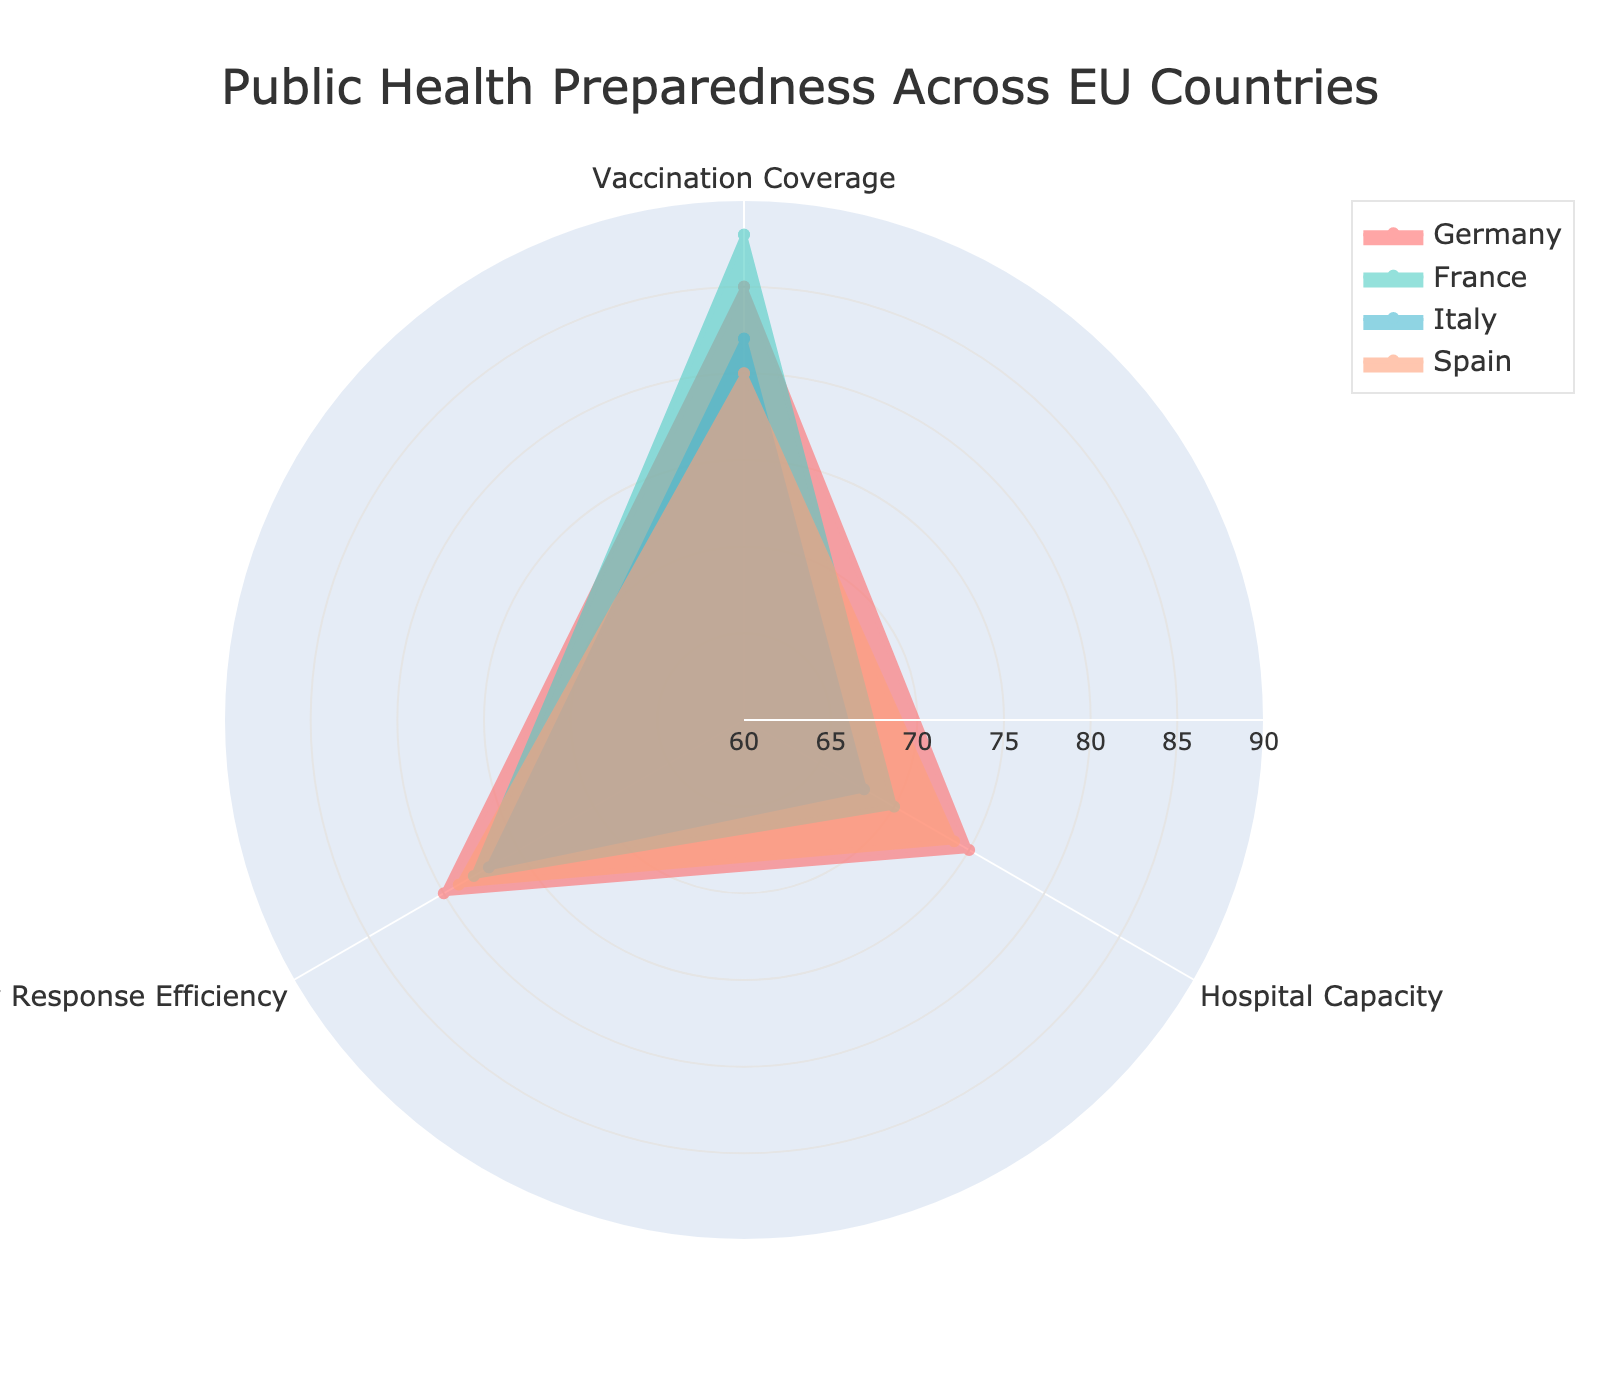What's the title of the radar chart? The title is located prominently at the top center of the radar chart. It reads 'Public Health Preparedness Across EU Countries'.
Answer: Public Health Preparedness Across EU Countries Which country has the highest Vaccination Coverage? By looking at the Vaccination Coverage indicator, the country with the highest value is plotted the farthest from the center. It can be observed that France has the highest value at 88%.
Answer: France What is the overall range of values for the Hospital Capacity indicator? The Hospital Capacity indicator can be observed along one axis of the radar chart. The lowest value is for Italy at 68%, and the highest value is for Germany at 75%. Thus, the range is from 68% to 75%.
Answer: 68% to 75% Compare the Emergency Response Efficiency of Germany and Spain. Which country performs better? In the Emergency Response Efficiency indicator, Germany and Spain can be compared by looking at their respective positions along this dimension. Germany scores 80%, whereas Spain scores 79%. Thus, Germany performs slightly better.
Answer: Germany What is the average Vaccination Coverage across all the countries? The Vaccination Coverage values for all countries are Germany (85), France (88), Italy (82), and Spain (80). The average is calculated as (85 + 88 + 82 + 80) / 4 = 83.75.
Answer: 83.75 Which country has the smallest value for any indicator, and what is that value? Observe the innermost data points on each axis. Italy has the smallest value for Hospital Capacity at 68%.
Answer: Italy, 68% Which indicator shows the largest variation across the countries? To determine variation, observe the spread of values for each indicator. Vaccination Coverage ranges from 80% to 88%, Hospital Capacity from 68% to 75%, and Emergency Response Efficiency from 77% to 80%. Vaccination Coverage has the largest spread of 8 percentage points.
Answer: Vaccination Coverage Identify which countries have values above 75% for all three indicators. Check each country’s values for all three indicators to see which are above 75%. Germany (85, 75, 80) and France (88, 70, 78) don’t meet the Hospital Capacity condition. Italy (82, 68, 77) and Spain (80, 74, 79) fail Hospital Capacity and Vaccination Coverage respectively. Thus, no country meets all criteria.
Answer: None What is the difference in Vaccination Coverage between the country with the highest and lowest values? The highest Vaccination Coverage is for France at 88%, and the lowest is for Spain at 80%. The difference is 88 - 80 = 8%.
Answer: 8% 